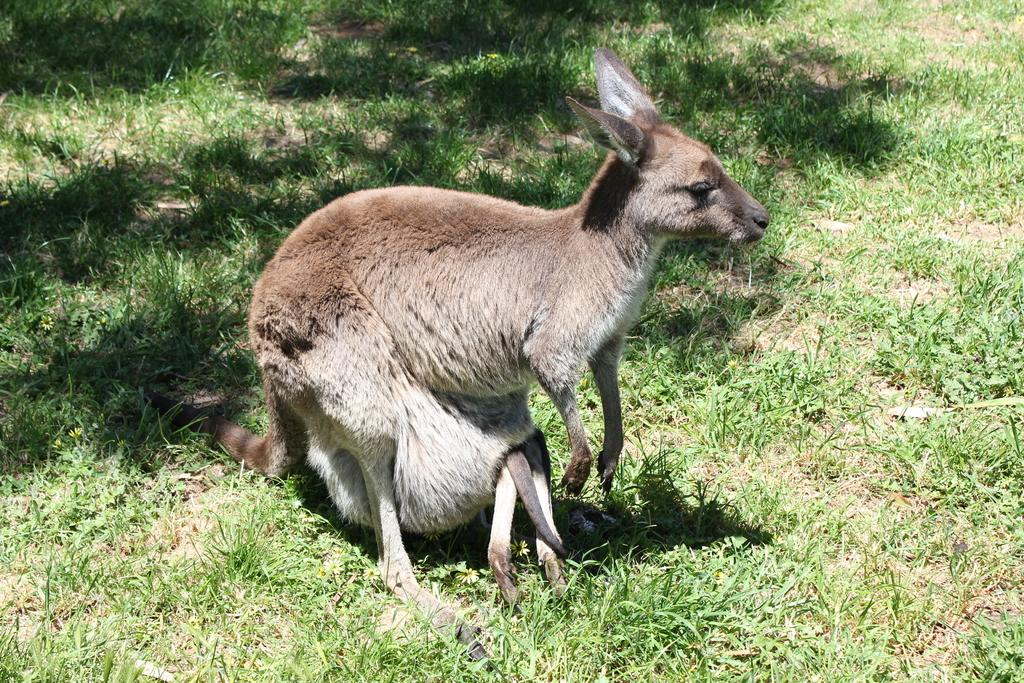What animal is present in the image? There is a kangaroo in the image. What type of terrain is the kangaroo standing on? The kangaroo is on the grass. What type of account does the kangaroo have in the image? There is no mention of an account in the image, as it features a kangaroo on the grass. 